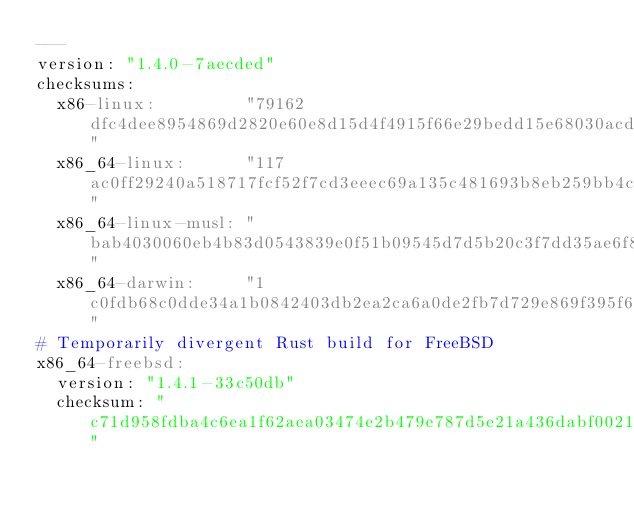<code> <loc_0><loc_0><loc_500><loc_500><_YAML_>---
version: "1.4.0-7aecded"
checksums:
  x86-linux:         "79162dfc4dee8954869d2820e60e8d15d4f4915f66e29bedd15e68030acd5b27"
  x86_64-linux:      "117ac0ff29240a518717fcf52f7cd3eeec69a135c481693b8eb259bb4c2b528c"
  x86_64-linux-musl: "bab4030060eb4b83d0543839e0f51b09545d7d5b20c3f7dd35ae6f81f3189499"
  x86_64-darwin:     "1c0fdb68c0dde34a1b0842403db2ea2ca6a0de2fb7d729e869f395f6d10383b5"
# Temporarily divergent Rust build for FreeBSD
x86_64-freebsd:
  version: "1.4.1-33c50db"
  checksum: "c71d958fdba4c6ea1f62aea03474e2b479e787d5e21a436dabf00218ea25d2b0"
</code> 